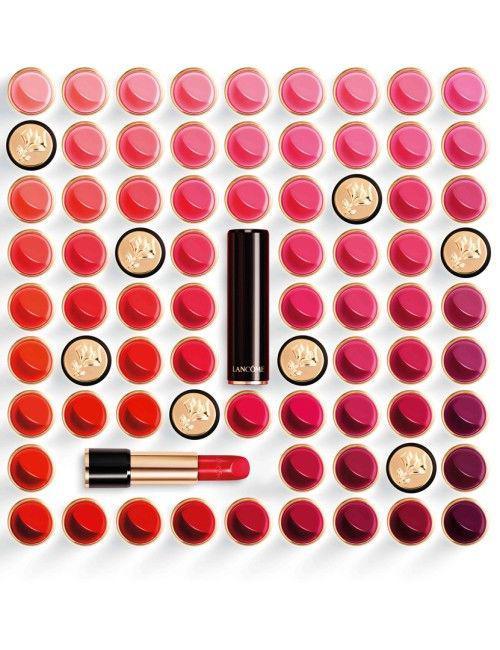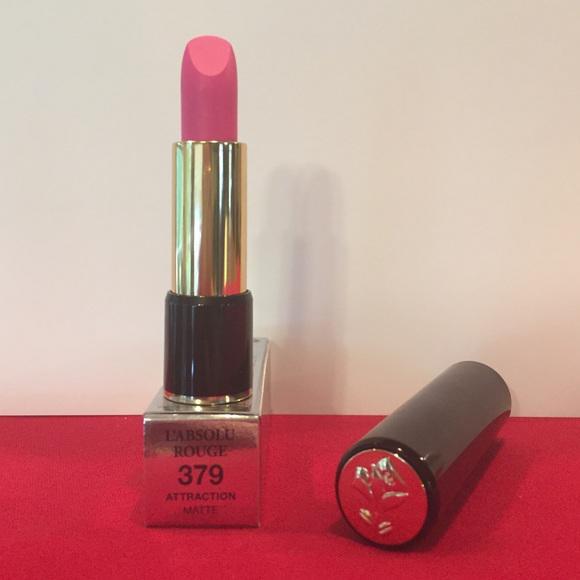The first image is the image on the left, the second image is the image on the right. Given the left and right images, does the statement "One image shows exactly six different lipstick color samples." hold true? Answer yes or no. No. The first image is the image on the left, the second image is the image on the right. Examine the images to the left and right. Is the description "There are 6 shades of lipstick presented in the image on the right." accurate? Answer yes or no. No. 